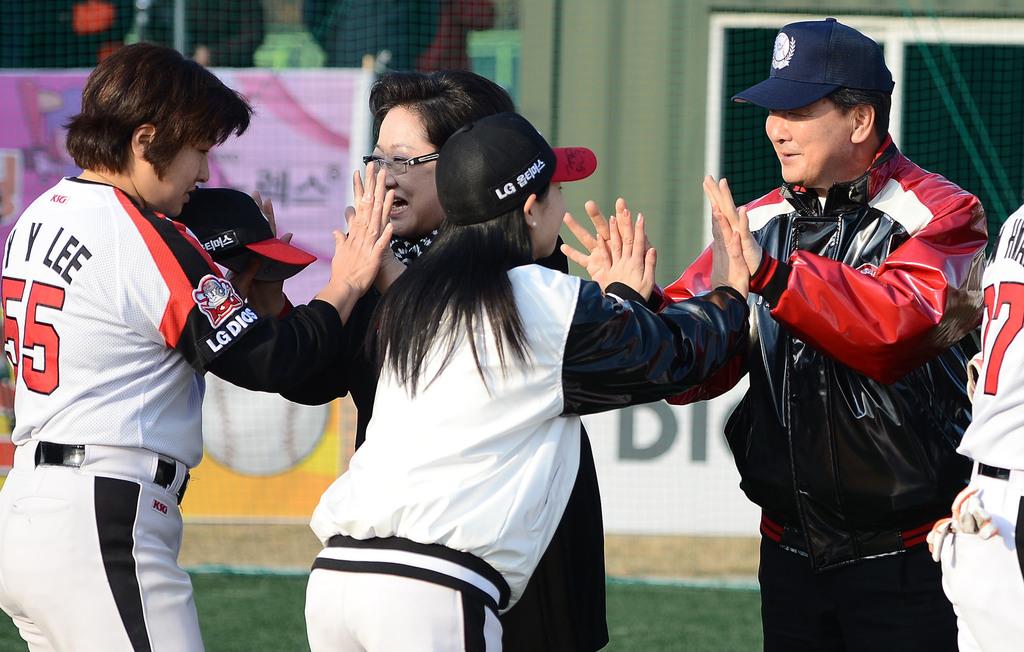What is the visible player number far-left?
Provide a short and direct response. 55. What is the name on the jersey?
Provide a short and direct response. Lee. 